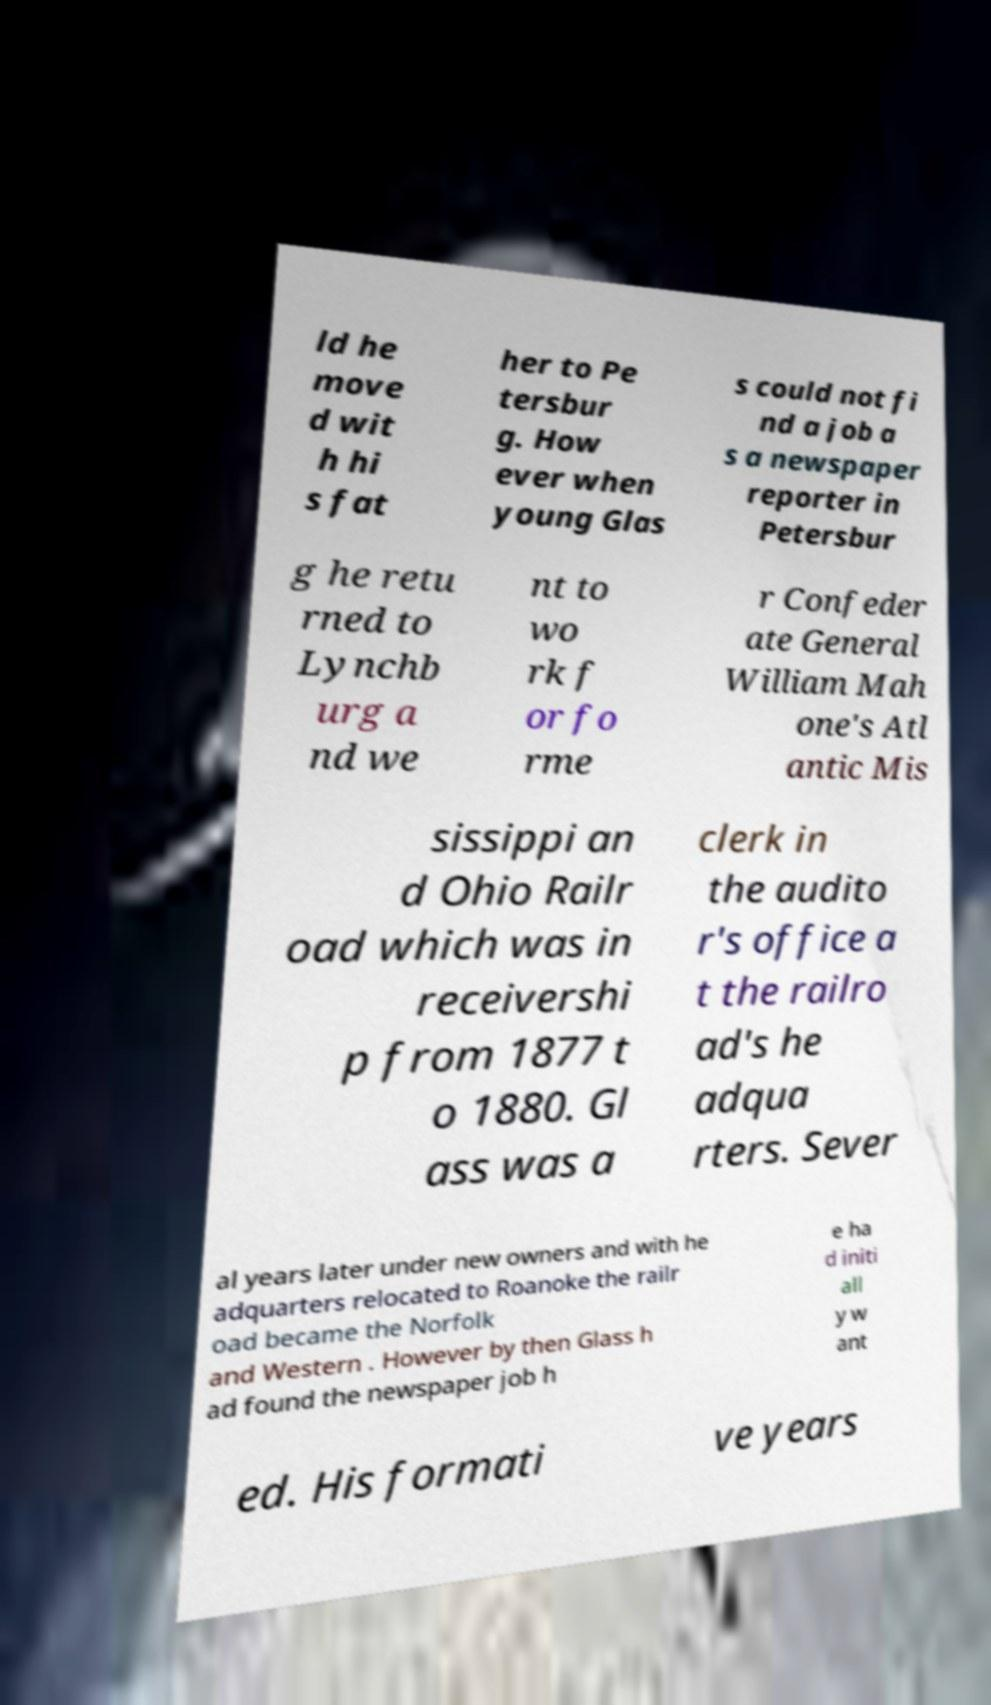What messages or text are displayed in this image? I need them in a readable, typed format. ld he move d wit h hi s fat her to Pe tersbur g. How ever when young Glas s could not fi nd a job a s a newspaper reporter in Petersbur g he retu rned to Lynchb urg a nd we nt to wo rk f or fo rme r Confeder ate General William Mah one's Atl antic Mis sissippi an d Ohio Railr oad which was in receivershi p from 1877 t o 1880. Gl ass was a clerk in the audito r's office a t the railro ad's he adqua rters. Sever al years later under new owners and with he adquarters relocated to Roanoke the railr oad became the Norfolk and Western . However by then Glass h ad found the newspaper job h e ha d initi all y w ant ed. His formati ve years 